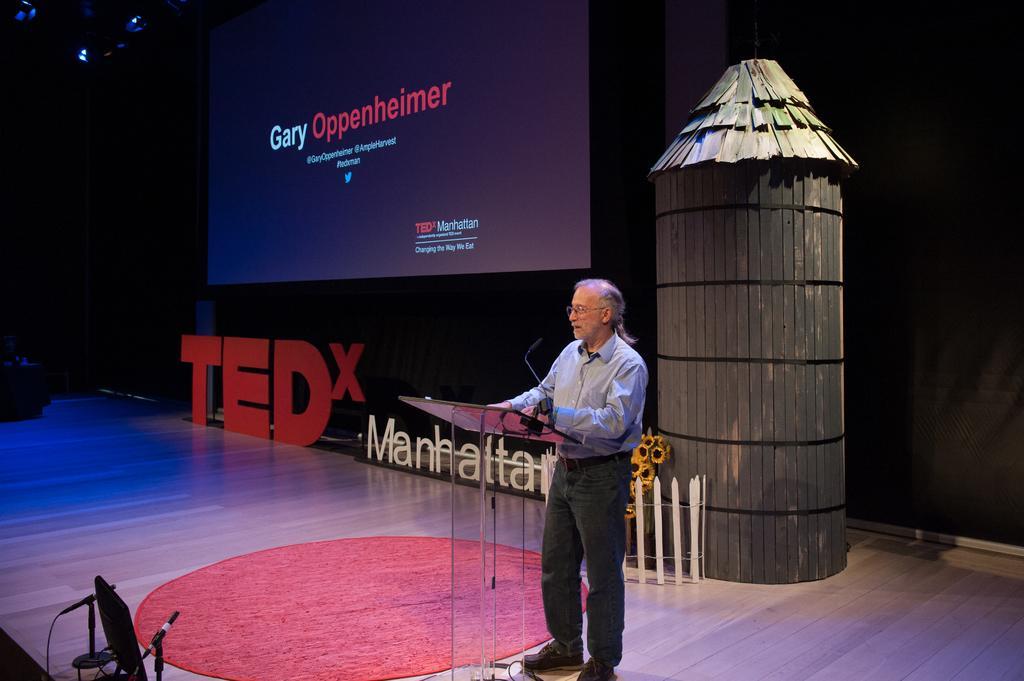In one or two sentences, can you explain what this image depicts? In the center of the image, we can see a man standing and wearing glasses and there is a podium and a mic. In the background, there is a screen with some text, some boards, a booth, a fence and we can see flowers and there is a wall and we can see some other stands and there are lights. At the bottom, there is a mat on the floor. 